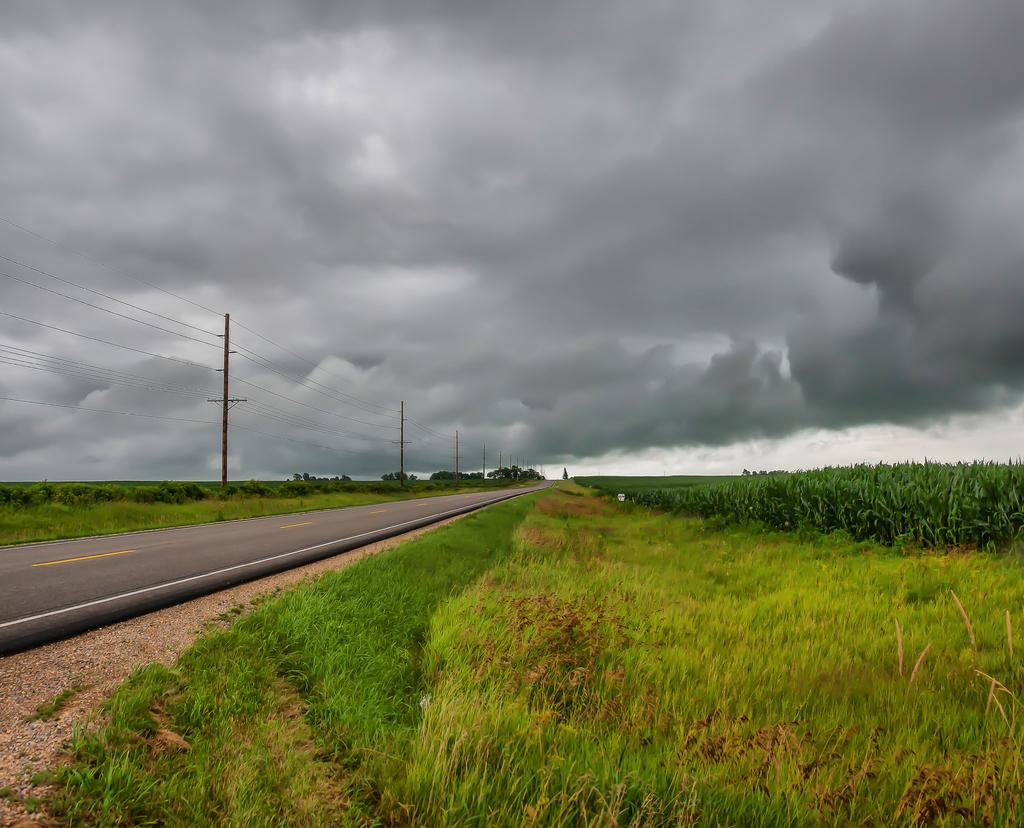What is the main subject of the image? The main subject of the image is an empty road. Are there any structures or objects visible along the road? Yes, there are electrical poles in the image. What type of natural environment is visible in the image? There are grass fields in the image. What type of birds can be seen flying over the grass fields in the image? There are no birds visible in the image; it only shows an empty road, electrical poles, and grass fields. 